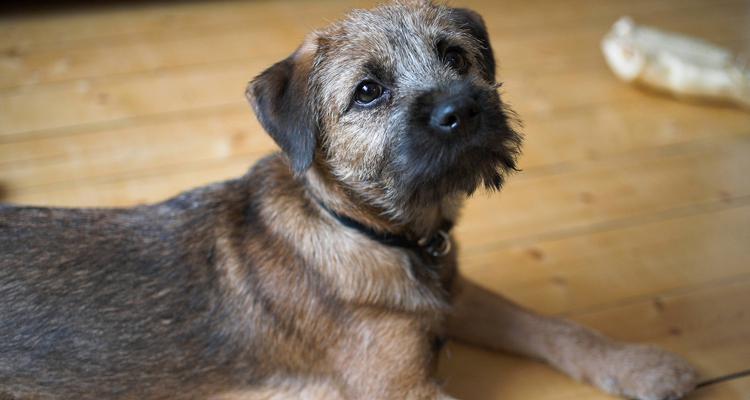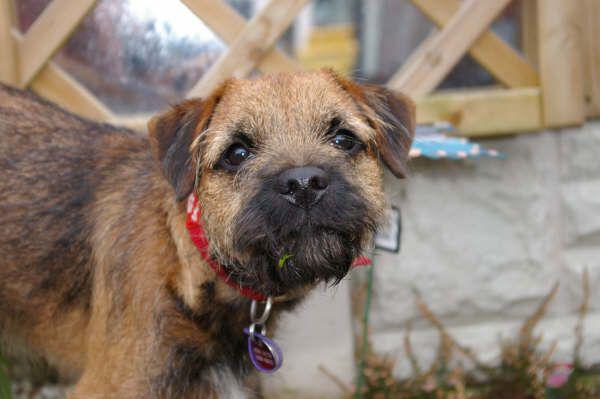The first image is the image on the left, the second image is the image on the right. Evaluate the accuracy of this statement regarding the images: "There are two dogs, and one of them is lying down.". Is it true? Answer yes or no. Yes. The first image is the image on the left, the second image is the image on the right. Examine the images to the left and right. Is the description "One dog is wearing a collar with a round tag clearly visible." accurate? Answer yes or no. Yes. 